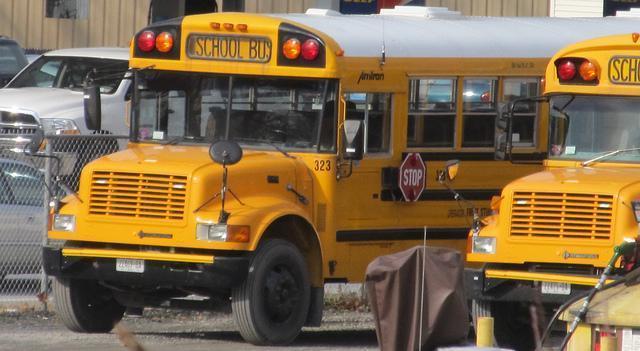How many buses are in the picture?
Give a very brief answer. 2. 